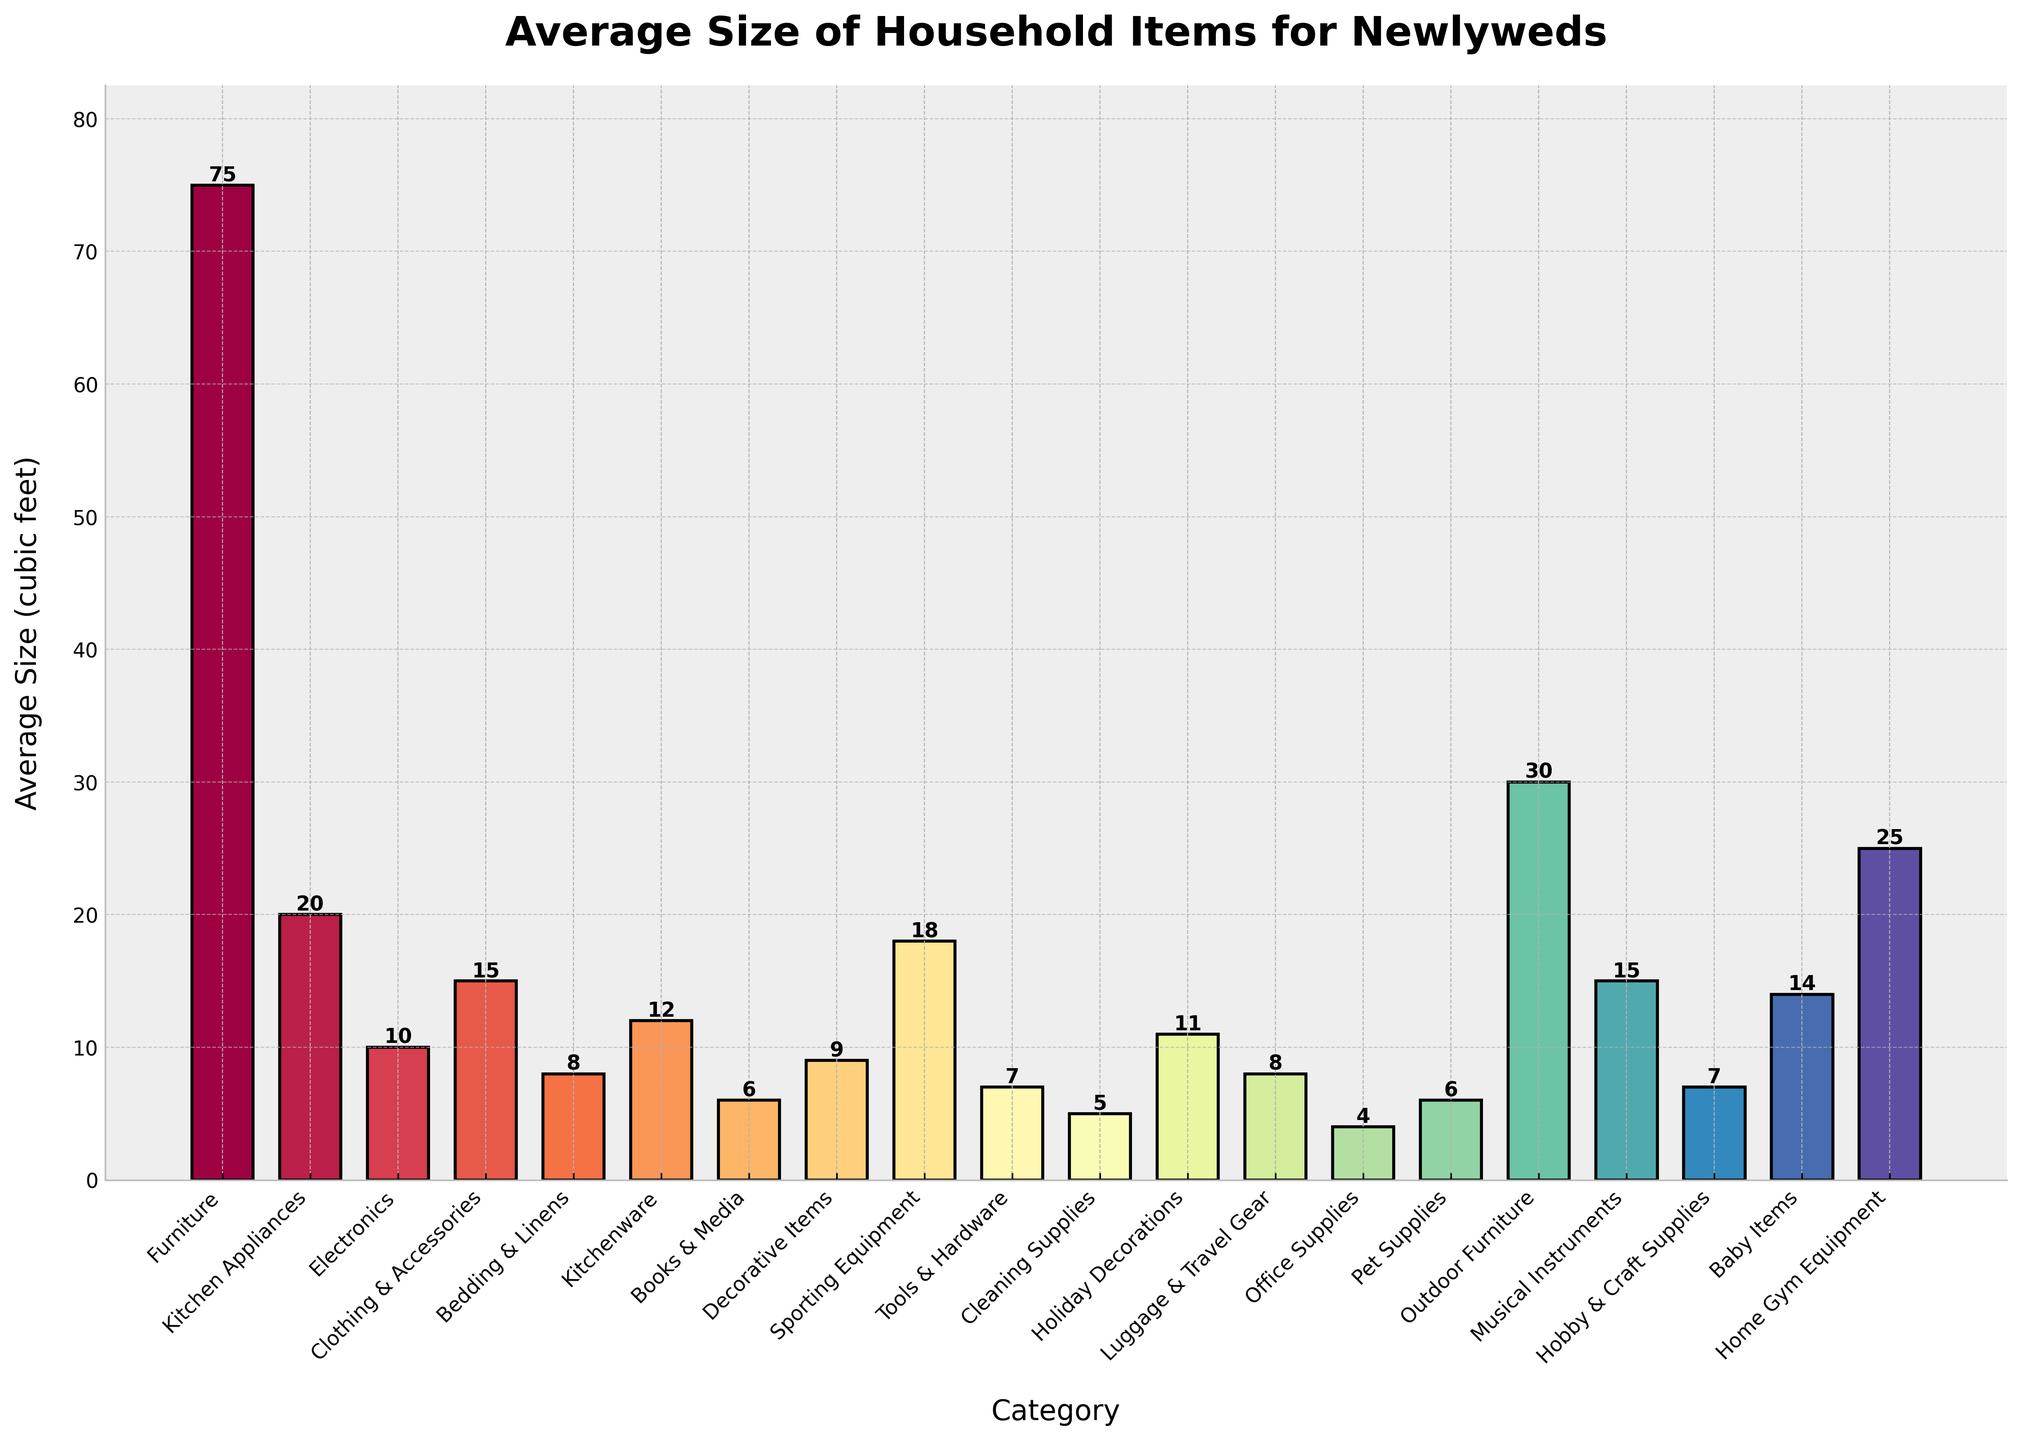What's the largest category by average size? The tallest bar represents the category with the largest average size, which is Furniture at 75 cubic feet.
Answer: Furniture Which category has an average size of just 4 cubic feet? The shortest bar, representing the average size of 4 cubic feet, corresponds to Office Supplies.
Answer: Office Supplies How much larger in size is Outdoor Furniture compared to Kitchen Appliances? Outdoor Furniture has an average size of 30 cubic feet while Kitchen Appliances have 20 cubic feet. The difference is 30 - 20 = 10 cubic feet.
Answer: 10 cubic feet What is the combined average size of Baby Items and Musical Instruments? Baby Items have an average size of 14 cubic feet and Musical Instruments have 15 cubic feet. Their combined size is 14 + 15 = 29 cubic feet.
Answer: 29 cubic feet Which category has an average size closest to the midpoint between Electronics and Holiday Decorations? Electronics have an average size of 10 cubic feet and Holiday Decorations have 11 cubic feet. The midpoint is (10+11)/2 = 10.5 cubic feet. Decorative Items, with an average size of 9 cubic feet, are closest to this value.
Answer: Decorative Items What is the difference in average size between Books & Media and Pet Supplies? Books & Media have an average size of 6 cubic feet while Pet Supplies also have 6 cubic feet. The difference is 6 - 6 = 0 cubic feet.
Answer: 0 cubic feet Between Bedding & Linens and Luggage & Travel Gear, which has a larger average size and by how much? Bedding & Linens have an average size of 8 cubic feet while Luggage & Travel Gear also have the same size. The size difference is 8 - 8 = 0 cubic feet.
Answer: Bedding & Linens, 0 cubic feet Which three categories have average sizes closest to each other? Looking at the bars, Clothing & Accessories, Musical Instruments, and Baby Items have sizes of 15, 15, and 14 cubic feet respectively; they're the closest to each other.
Answer: Clothing & Accessories, Musical Instruments, Baby Items What is the total average size of the categories related to outdoor activities? The relevant categories are Outdoor Furniture and Sporting Equipment. Outdoor Furniture has 30 cubic feet and Sporting Equipment has 18 cubic feet. So, 30 + 18 = 48 cubic feet.
Answer: 48 cubic feet What is the relationship between the average sizes of Tools & Hardware and Hobby & Craft Supplies? Tools & Hardware and Hobby & Craft Supplies both have an average size of 7 cubic feet, indicating that they are equal in average size.
Answer: Equal 